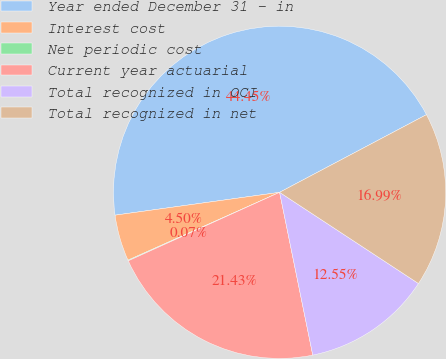Convert chart. <chart><loc_0><loc_0><loc_500><loc_500><pie_chart><fcel>Year ended December 31 - in<fcel>Interest cost<fcel>Net periodic cost<fcel>Current year actuarial<fcel>Total recognized in OCI<fcel>Total recognized in net<nl><fcel>44.45%<fcel>4.5%<fcel>0.07%<fcel>21.43%<fcel>12.55%<fcel>16.99%<nl></chart> 